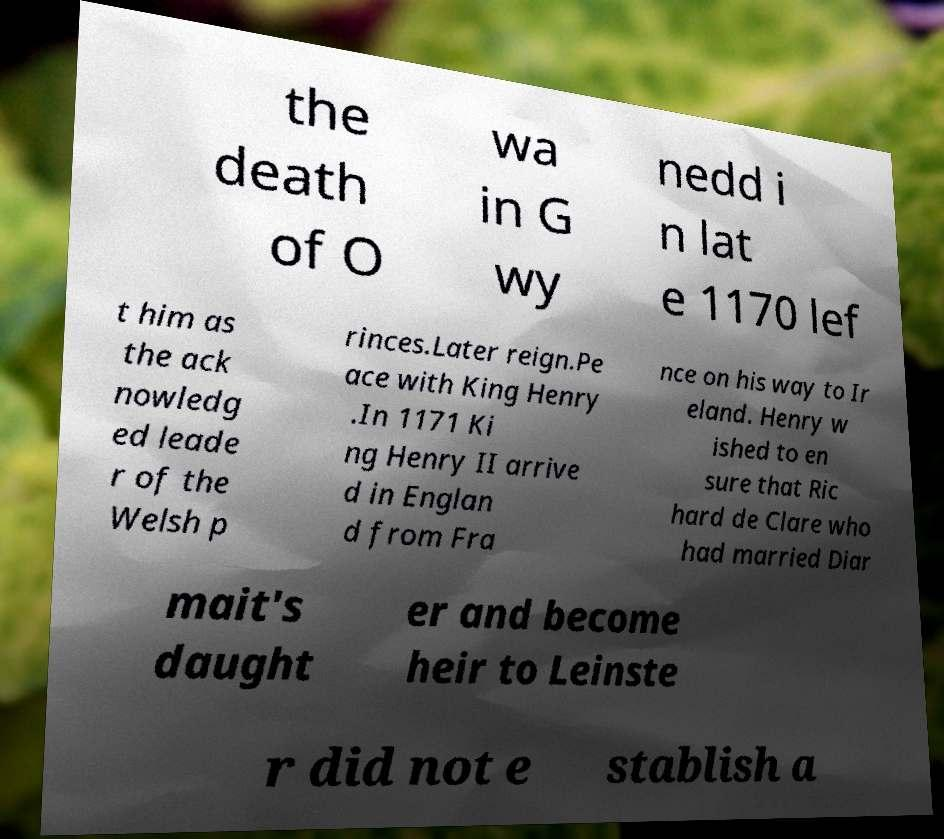Can you read and provide the text displayed in the image?This photo seems to have some interesting text. Can you extract and type it out for me? the death of O wa in G wy nedd i n lat e 1170 lef t him as the ack nowledg ed leade r of the Welsh p rinces.Later reign.Pe ace with King Henry .In 1171 Ki ng Henry II arrive d in Englan d from Fra nce on his way to Ir eland. Henry w ished to en sure that Ric hard de Clare who had married Diar mait's daught er and become heir to Leinste r did not e stablish a 